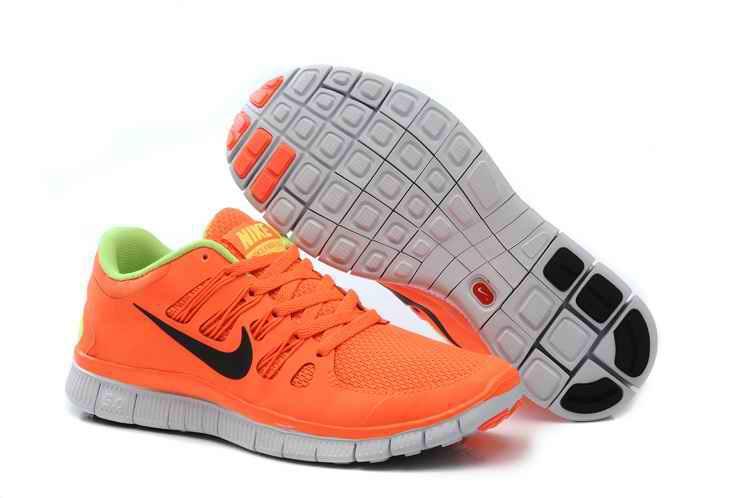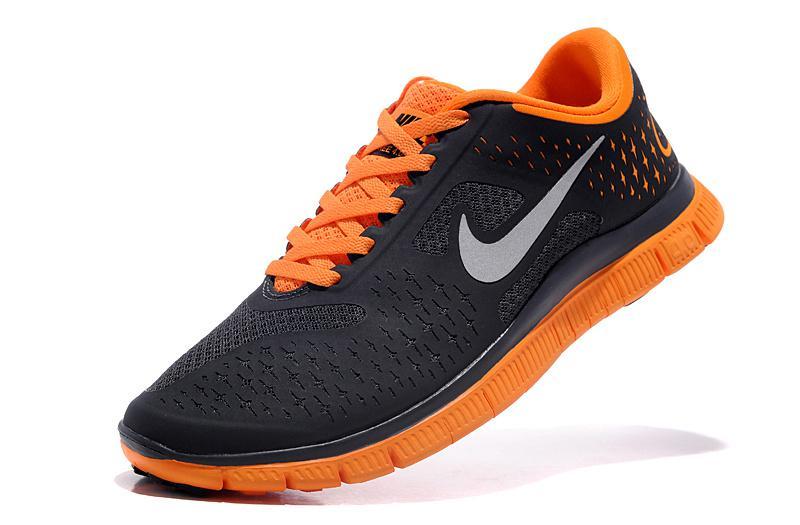The first image is the image on the left, the second image is the image on the right. Considering the images on both sides, is "There is exactly one shoe in the image on the right." valid? Answer yes or no. Yes. The first image is the image on the left, the second image is the image on the right. For the images displayed, is the sentence "One image features an orange shoe with a gray sole." factually correct? Answer yes or no. Yes. 